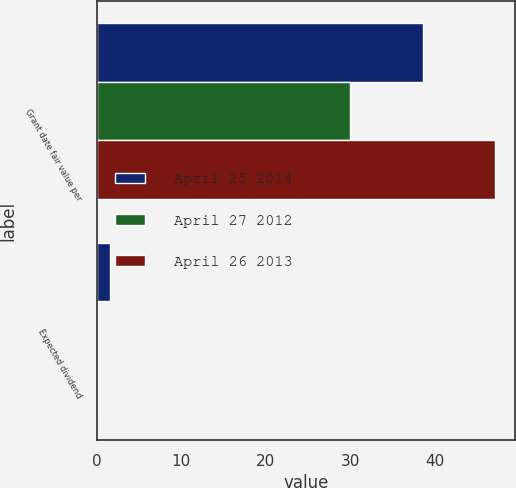Convert chart to OTSL. <chart><loc_0><loc_0><loc_500><loc_500><stacked_bar_chart><ecel><fcel>Grant date fair value per<fcel>Expected dividend<nl><fcel>April 25 2014<fcel>38.61<fcel>1.6<nl><fcel>April 27 2012<fcel>29.94<fcel>0<nl><fcel>April 26 2013<fcel>47.17<fcel>0<nl></chart> 